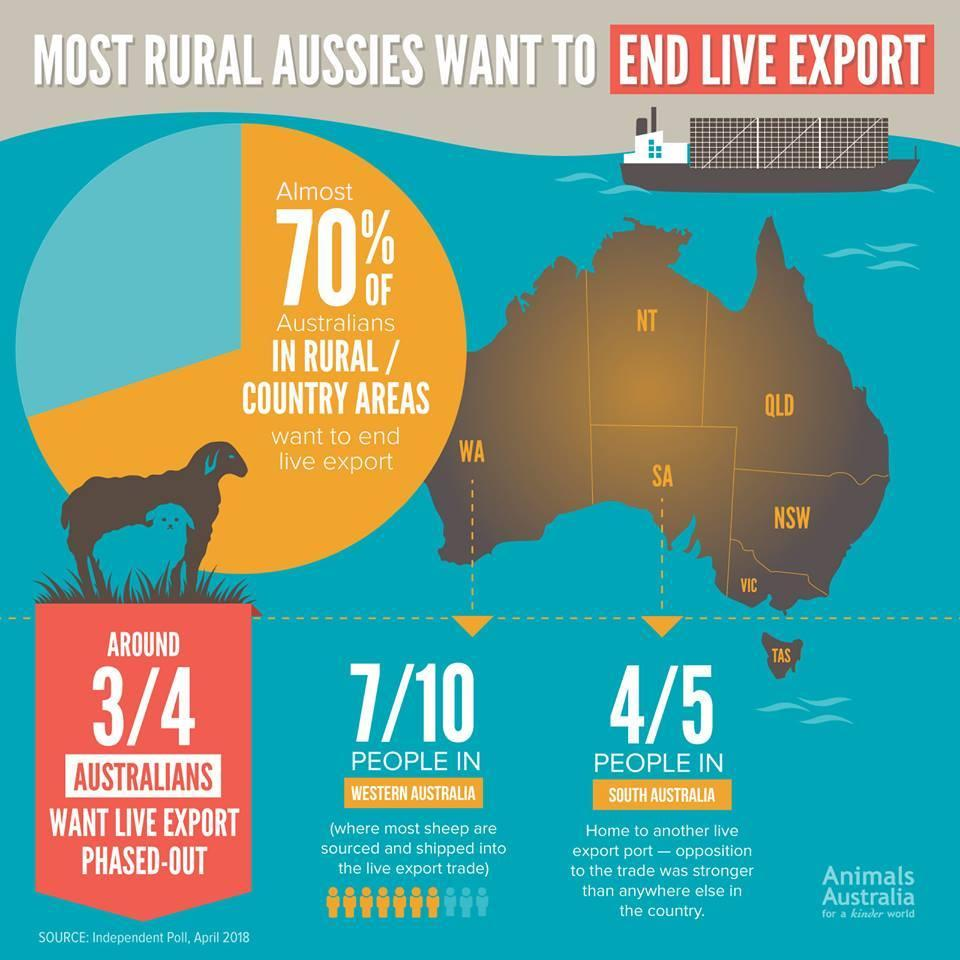Give some essential details in this illustration. According to a recent survey, 70% of people in Western Australia support the phased out of live exports. There are two sheep shown in the image. According to recent surveys, approximately 80% of people in South Australia want the live export industry to be phased out. Sheep are predominantly sourced from Western Australia. According to recent surveys, 30% of people in rural or country areas are against ending live export. 